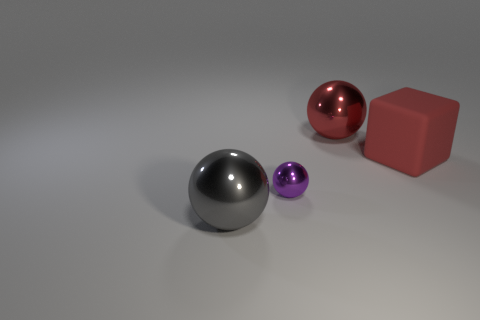Add 2 purple spheres. How many objects exist? 6 Subtract all cubes. How many objects are left? 3 Add 2 tiny spheres. How many tiny spheres exist? 3 Subtract 0 red cylinders. How many objects are left? 4 Subtract all large gray things. Subtract all small brown shiny blocks. How many objects are left? 3 Add 3 big gray metal spheres. How many big gray metal spheres are left? 4 